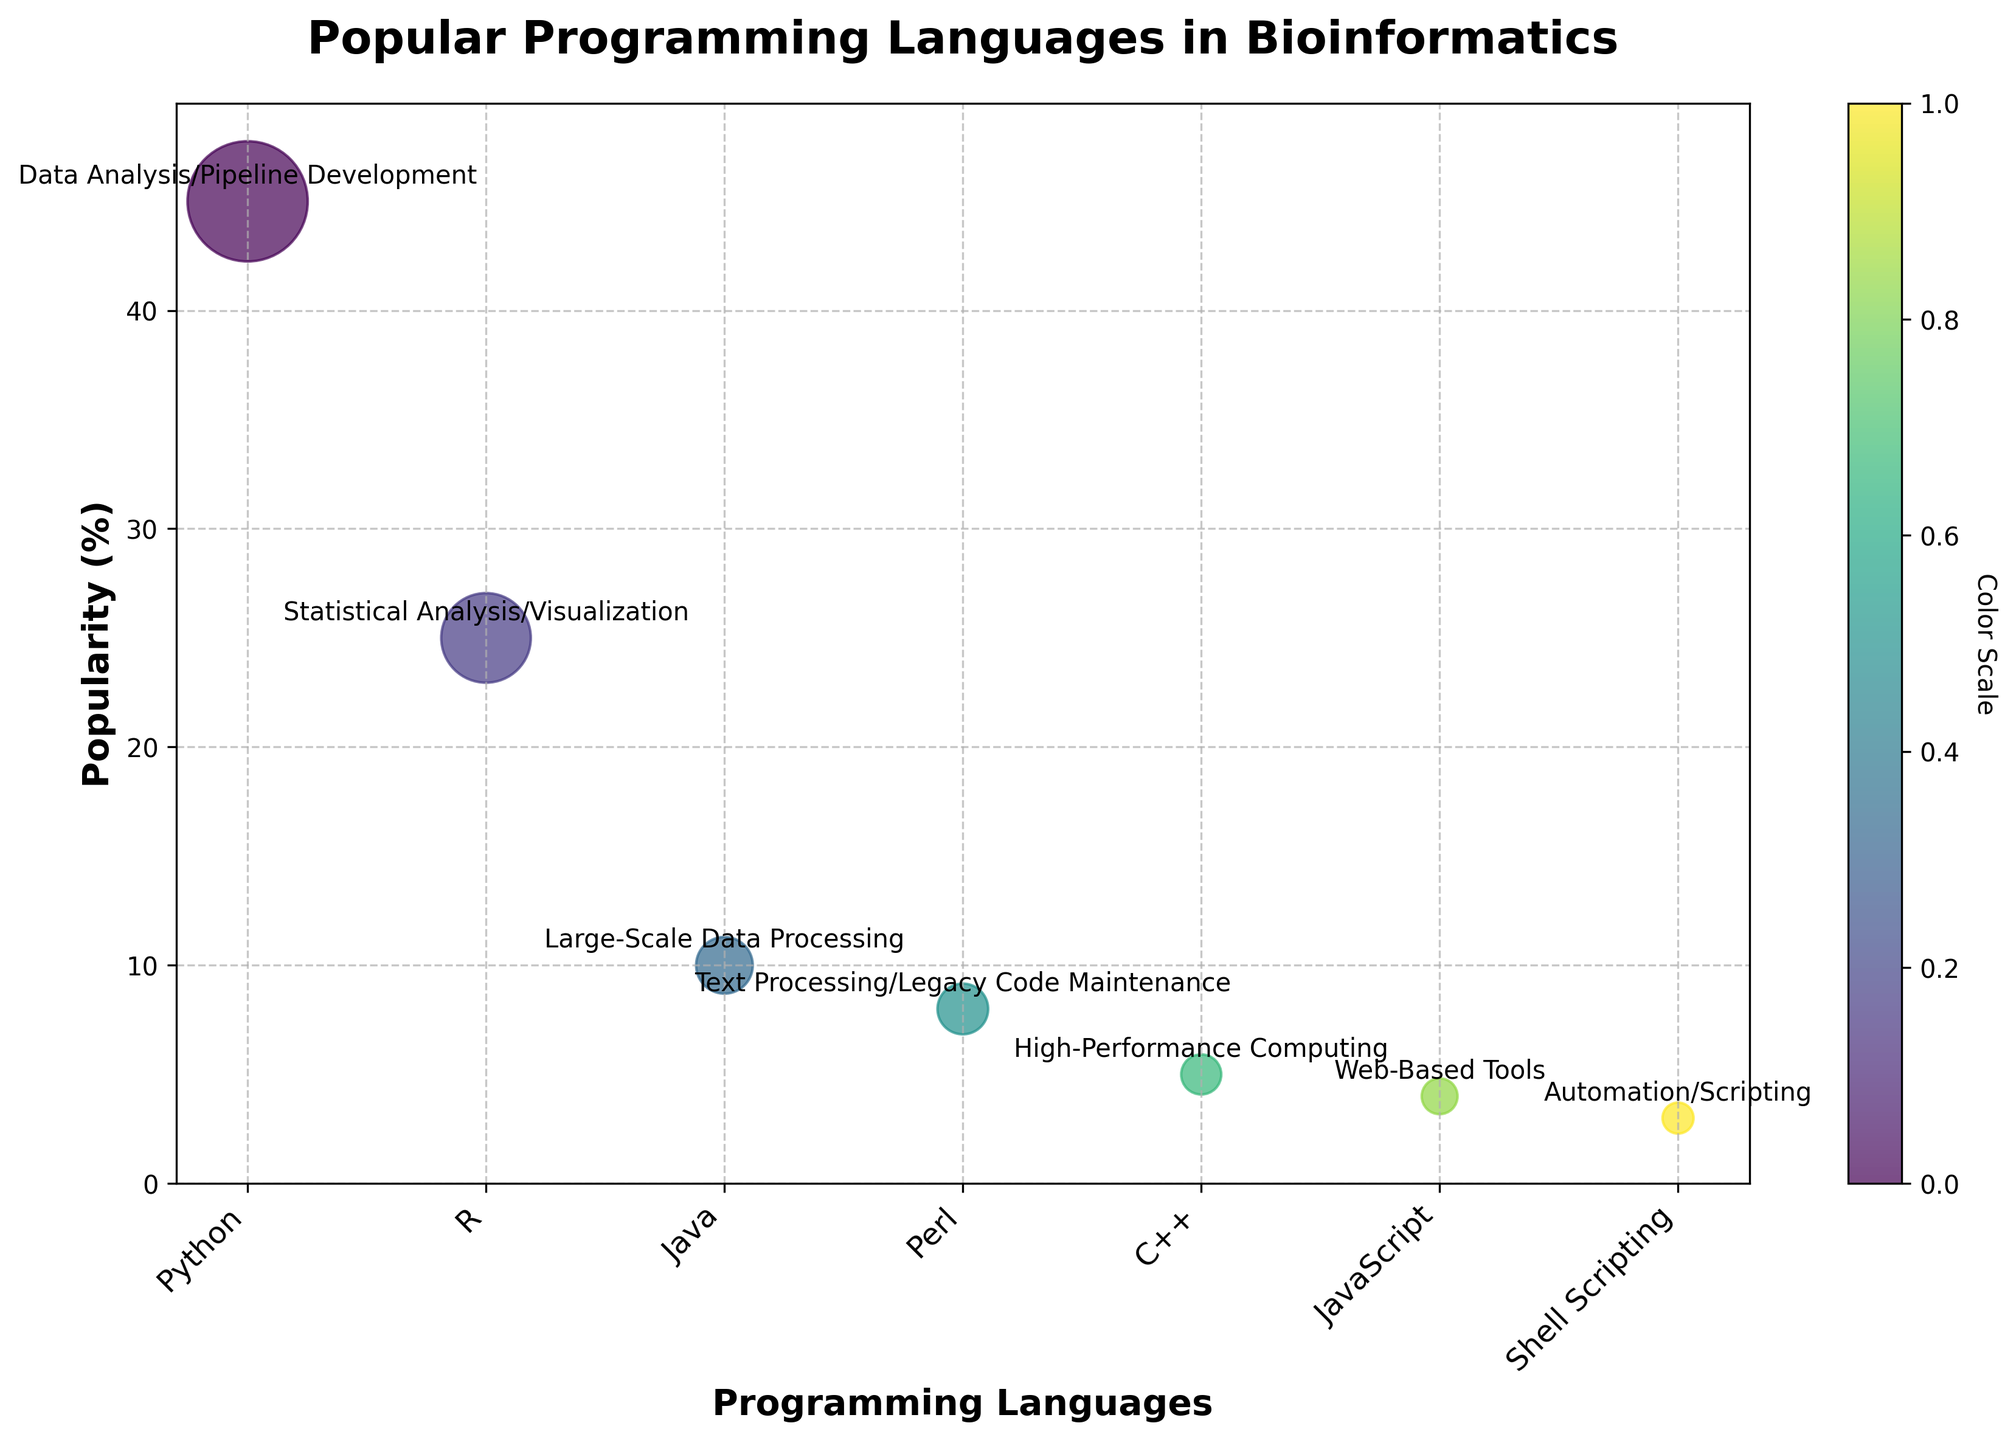What's the most popular programming language among bioinformatics developers? The highest bubble on the y-axis represents 'Python' at 45% popularity.
Answer: Python Which programming language has the least popularity, and what is its main usage? The bubble at the lowest point on the y-axis is 'Shell Scripting' with 3% popularity. Its main usage is Automation/Scripting.
Answer: Shell Scripting, Automation/Scripting What is the total percentage popularity of Python, R, and Java combined? Summing the popularity percentages of Python (45%), R (25%), and Java (10%) gives: 45 + 25 + 10 = 80%.
Answer: 80% Which programming language is used for high-performance computing, and what is its popularity percentage? The bubble labeled 'High-Performance Computing' corresponds to 'C++' with a popularity of 5%.
Answer: C++, 5% Between R and JavaScript, which is more popular, and by how much? 'R' has 25% popularity, whereas 'JavaScript' has 4%. The difference is 25 - 4 = 21%.
Answer: R, 21% What is the average popularity percentage of all programming languages shown? Adding all popularity percentages (45+25+10+8+5+4+3) and dividing by the number of languages (7) gives: (45+25+10+8+5+4+3)/7 ≈ 14.29%.
Answer: 14.29% Of the programming languages listed, how many are primarily used for text processing or scripting? 'Perl' is used for Text Processing, and 'Shell Scripting' is used for Automation/Scripting, making a total of 2.
Answer: 2 Which programming language is used for large-scale data processing, and what is its main usage indicated in the figure? The programming language labeled 'Large-Scale Data Processing' is 'Java'. Its main usage is as indicated in the bubble’s label 'Large-Scale Data Processing'.
Answer: Java, Large-Scale Data Processing If the popularity of Java were to double, what would its new popularity percentage be, and where would it rank among the seven languages? Doubling Java's popularity (10%) gives 10 x 2 = 20%. It would be the 3rd most popular language after Python (45%) and R (25%).
Answer: 20%, 3rd 